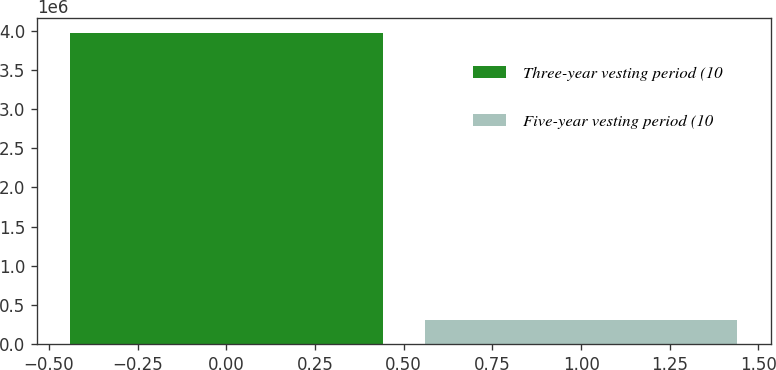<chart> <loc_0><loc_0><loc_500><loc_500><bar_chart><fcel>Three-year vesting period (10<fcel>Five-year vesting period (10<nl><fcel>3.96502e+06<fcel>306816<nl></chart> 